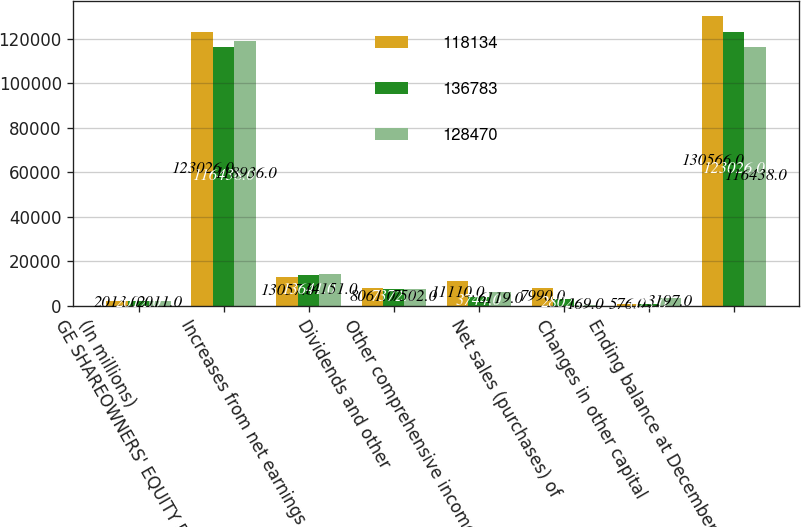Convert chart. <chart><loc_0><loc_0><loc_500><loc_500><stacked_bar_chart><ecel><fcel>(In millions)<fcel>GE SHAREOWNERS' EQUITY BALANCE<fcel>Increases from net earnings<fcel>Dividends and other<fcel>Other comprehensive income<fcel>Net sales (purchases) of<fcel>Changes in other capital<fcel>Ending balance at December 31<nl><fcel>118134<fcel>2013<fcel>123026<fcel>13057<fcel>8061<fcel>11110<fcel>7990<fcel>576<fcel>130566<nl><fcel>136783<fcel>2012<fcel>116438<fcel>13641<fcel>7372<fcel>3744<fcel>2802<fcel>623<fcel>123026<nl><fcel>128470<fcel>2011<fcel>118936<fcel>14151<fcel>7502<fcel>6119<fcel>169<fcel>3197<fcel>116438<nl></chart> 